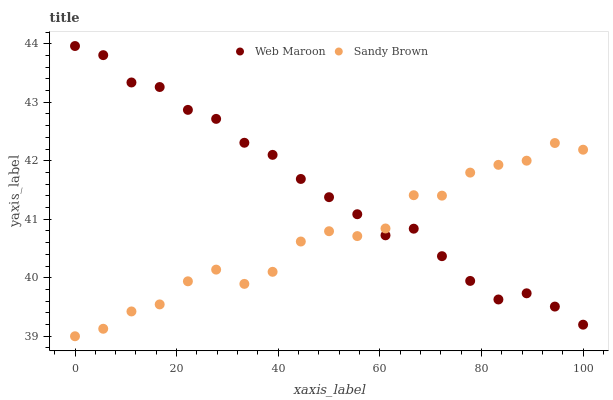Does Sandy Brown have the minimum area under the curve?
Answer yes or no. Yes. Does Web Maroon have the maximum area under the curve?
Answer yes or no. Yes. Does Web Maroon have the minimum area under the curve?
Answer yes or no. No. Is Web Maroon the smoothest?
Answer yes or no. Yes. Is Sandy Brown the roughest?
Answer yes or no. Yes. Is Web Maroon the roughest?
Answer yes or no. No. Does Sandy Brown have the lowest value?
Answer yes or no. Yes. Does Web Maroon have the lowest value?
Answer yes or no. No. Does Web Maroon have the highest value?
Answer yes or no. Yes. Does Web Maroon intersect Sandy Brown?
Answer yes or no. Yes. Is Web Maroon less than Sandy Brown?
Answer yes or no. No. Is Web Maroon greater than Sandy Brown?
Answer yes or no. No. 